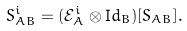<formula> <loc_0><loc_0><loc_500><loc_500>S _ { A B } ^ { i } = ( { \mathcal { E } } _ { A } ^ { i } \otimes { \mathrm I d } _ { B } ) [ S _ { A B } ] .</formula> 